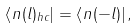Convert formula to latex. <formula><loc_0><loc_0><loc_500><loc_500>\left \langle n ( l ) _ { h c } \right | = \left \langle n ( - l ) \right | ,</formula> 